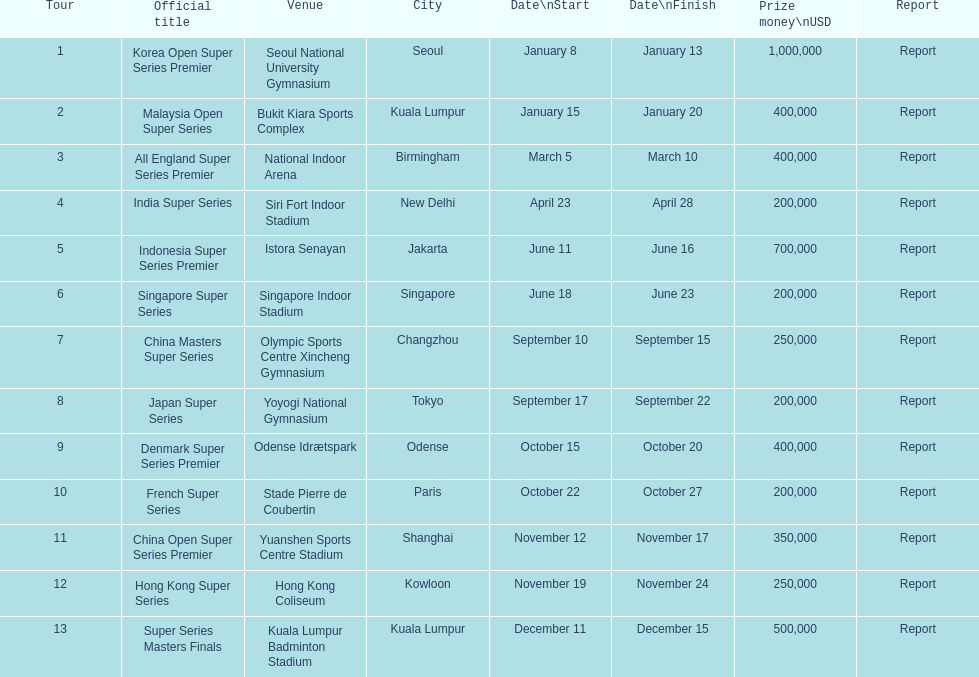How many series obtained no less than $500,000 in reward money? 3. 